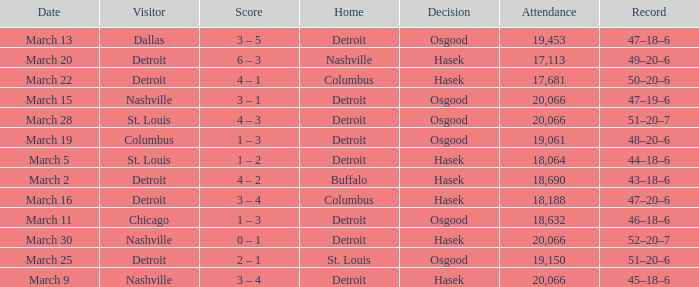What was the decision of the Red Wings game when they had a record of 45–18–6? Hasek. 